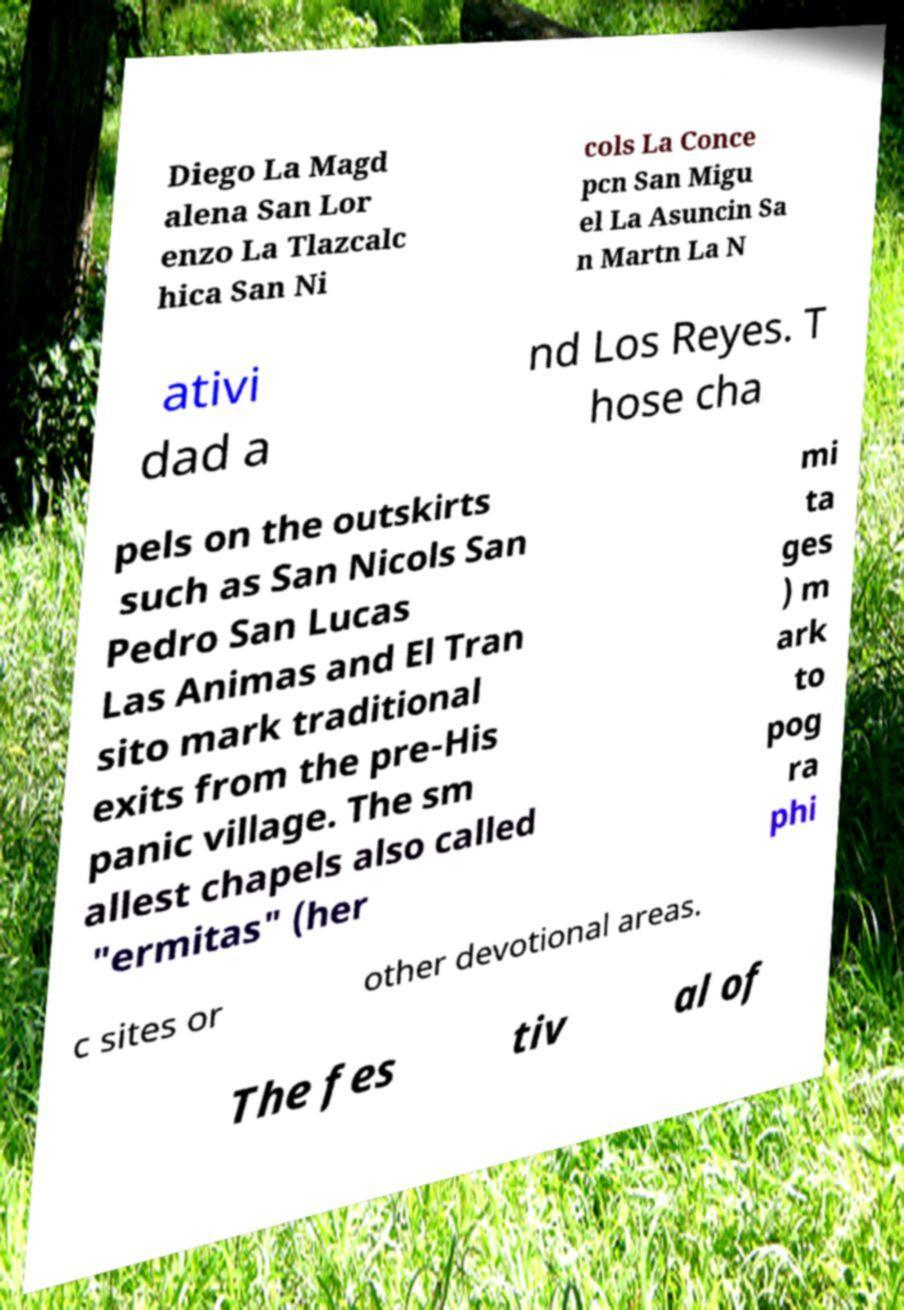Can you read and provide the text displayed in the image?This photo seems to have some interesting text. Can you extract and type it out for me? Diego La Magd alena San Lor enzo La Tlazcalc hica San Ni cols La Conce pcn San Migu el La Asuncin Sa n Martn La N ativi dad a nd Los Reyes. T hose cha pels on the outskirts such as San Nicols San Pedro San Lucas Las Animas and El Tran sito mark traditional exits from the pre-His panic village. The sm allest chapels also called "ermitas" (her mi ta ges ) m ark to pog ra phi c sites or other devotional areas. The fes tiv al of 